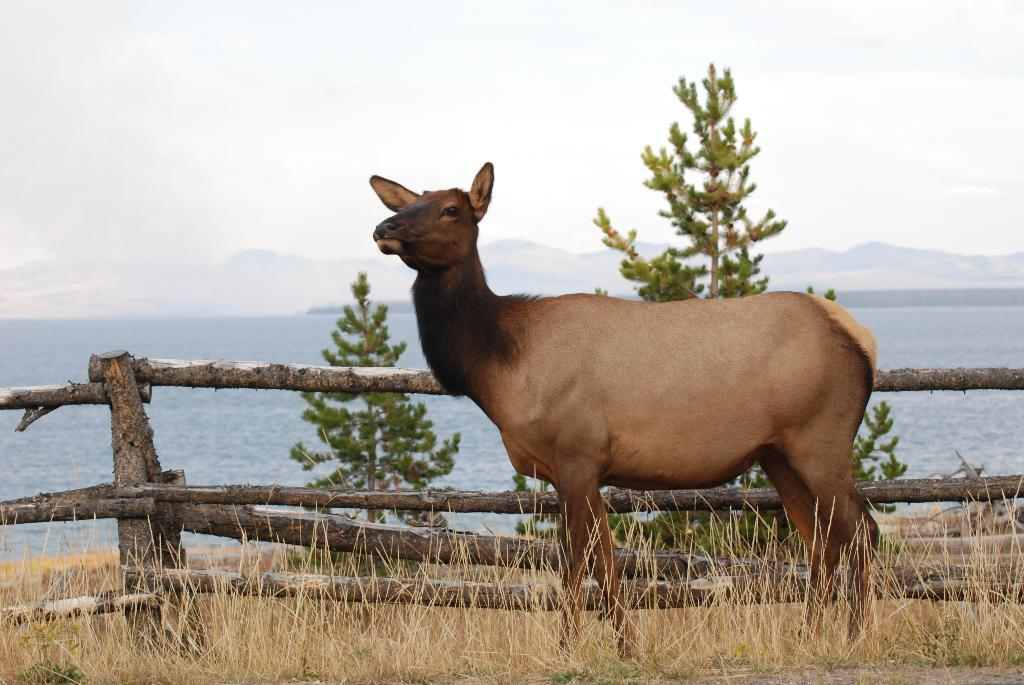What type of animal can be seen in the image? There is a brown deer in the image. Where is the deer positioned in relation to the image? The deer is standing in the front. What type of fencing is present in the image? There is bamboo fencing in the image. What type of vegetation is present in the image? There are green plants in the image. What can be seen in the background of the image? There is a sea visible in the background of the image. How much profit did the brothers make from selling the deer in the image? There is no mention of brothers or selling the deer in the image, so it is not possible to determine any profit made. 